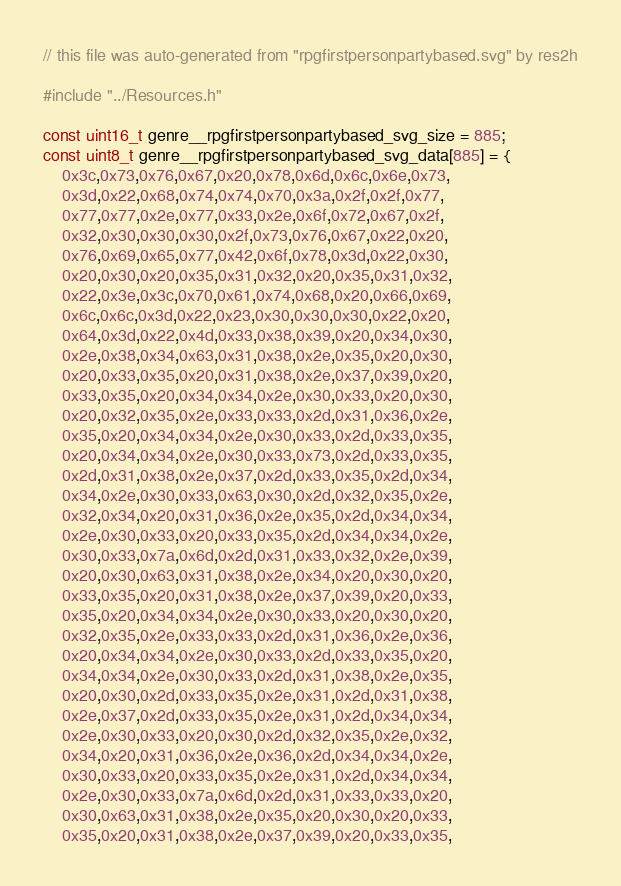Convert code to text. <code><loc_0><loc_0><loc_500><loc_500><_C++_>// this file was auto-generated from "rpgfirstpersonpartybased.svg" by res2h

#include "../Resources.h"

const uint16_t genre__rpgfirstpersonpartybased_svg_size = 885;
const uint8_t genre__rpgfirstpersonpartybased_svg_data[885] = {
    0x3c,0x73,0x76,0x67,0x20,0x78,0x6d,0x6c,0x6e,0x73,
    0x3d,0x22,0x68,0x74,0x74,0x70,0x3a,0x2f,0x2f,0x77,
    0x77,0x77,0x2e,0x77,0x33,0x2e,0x6f,0x72,0x67,0x2f,
    0x32,0x30,0x30,0x30,0x2f,0x73,0x76,0x67,0x22,0x20,
    0x76,0x69,0x65,0x77,0x42,0x6f,0x78,0x3d,0x22,0x30,
    0x20,0x30,0x20,0x35,0x31,0x32,0x20,0x35,0x31,0x32,
    0x22,0x3e,0x3c,0x70,0x61,0x74,0x68,0x20,0x66,0x69,
    0x6c,0x6c,0x3d,0x22,0x23,0x30,0x30,0x30,0x22,0x20,
    0x64,0x3d,0x22,0x4d,0x33,0x38,0x39,0x20,0x34,0x30,
    0x2e,0x38,0x34,0x63,0x31,0x38,0x2e,0x35,0x20,0x30,
    0x20,0x33,0x35,0x20,0x31,0x38,0x2e,0x37,0x39,0x20,
    0x33,0x35,0x20,0x34,0x34,0x2e,0x30,0x33,0x20,0x30,
    0x20,0x32,0x35,0x2e,0x33,0x33,0x2d,0x31,0x36,0x2e,
    0x35,0x20,0x34,0x34,0x2e,0x30,0x33,0x2d,0x33,0x35,
    0x20,0x34,0x34,0x2e,0x30,0x33,0x73,0x2d,0x33,0x35,
    0x2d,0x31,0x38,0x2e,0x37,0x2d,0x33,0x35,0x2d,0x34,
    0x34,0x2e,0x30,0x33,0x63,0x30,0x2d,0x32,0x35,0x2e,
    0x32,0x34,0x20,0x31,0x36,0x2e,0x35,0x2d,0x34,0x34,
    0x2e,0x30,0x33,0x20,0x33,0x35,0x2d,0x34,0x34,0x2e,
    0x30,0x33,0x7a,0x6d,0x2d,0x31,0x33,0x32,0x2e,0x39,
    0x20,0x30,0x63,0x31,0x38,0x2e,0x34,0x20,0x30,0x20,
    0x33,0x35,0x20,0x31,0x38,0x2e,0x37,0x39,0x20,0x33,
    0x35,0x20,0x34,0x34,0x2e,0x30,0x33,0x20,0x30,0x20,
    0x32,0x35,0x2e,0x33,0x33,0x2d,0x31,0x36,0x2e,0x36,
    0x20,0x34,0x34,0x2e,0x30,0x33,0x2d,0x33,0x35,0x20,
    0x34,0x34,0x2e,0x30,0x33,0x2d,0x31,0x38,0x2e,0x35,
    0x20,0x30,0x2d,0x33,0x35,0x2e,0x31,0x2d,0x31,0x38,
    0x2e,0x37,0x2d,0x33,0x35,0x2e,0x31,0x2d,0x34,0x34,
    0x2e,0x30,0x33,0x20,0x30,0x2d,0x32,0x35,0x2e,0x32,
    0x34,0x20,0x31,0x36,0x2e,0x36,0x2d,0x34,0x34,0x2e,
    0x30,0x33,0x20,0x33,0x35,0x2e,0x31,0x2d,0x34,0x34,
    0x2e,0x30,0x33,0x7a,0x6d,0x2d,0x31,0x33,0x33,0x20,
    0x30,0x63,0x31,0x38,0x2e,0x35,0x20,0x30,0x20,0x33,
    0x35,0x20,0x31,0x38,0x2e,0x37,0x39,0x20,0x33,0x35,</code> 